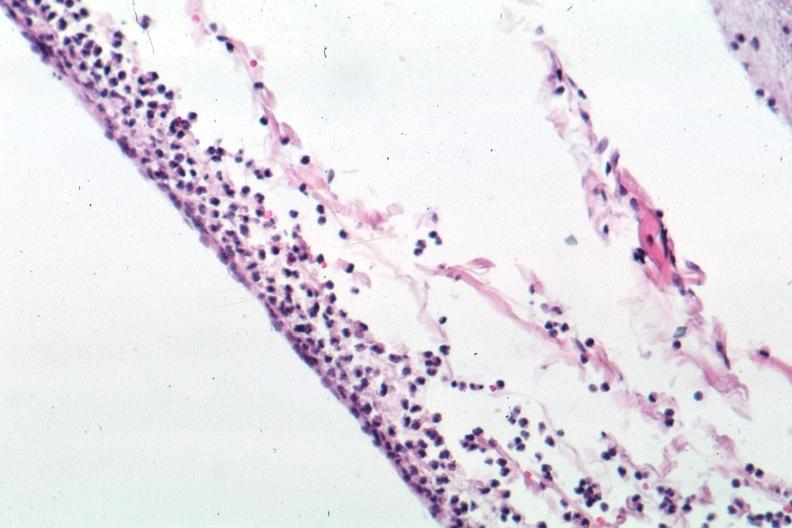does interstitial cell tumor show well shown meningitis purulent?
Answer the question using a single word or phrase. No 